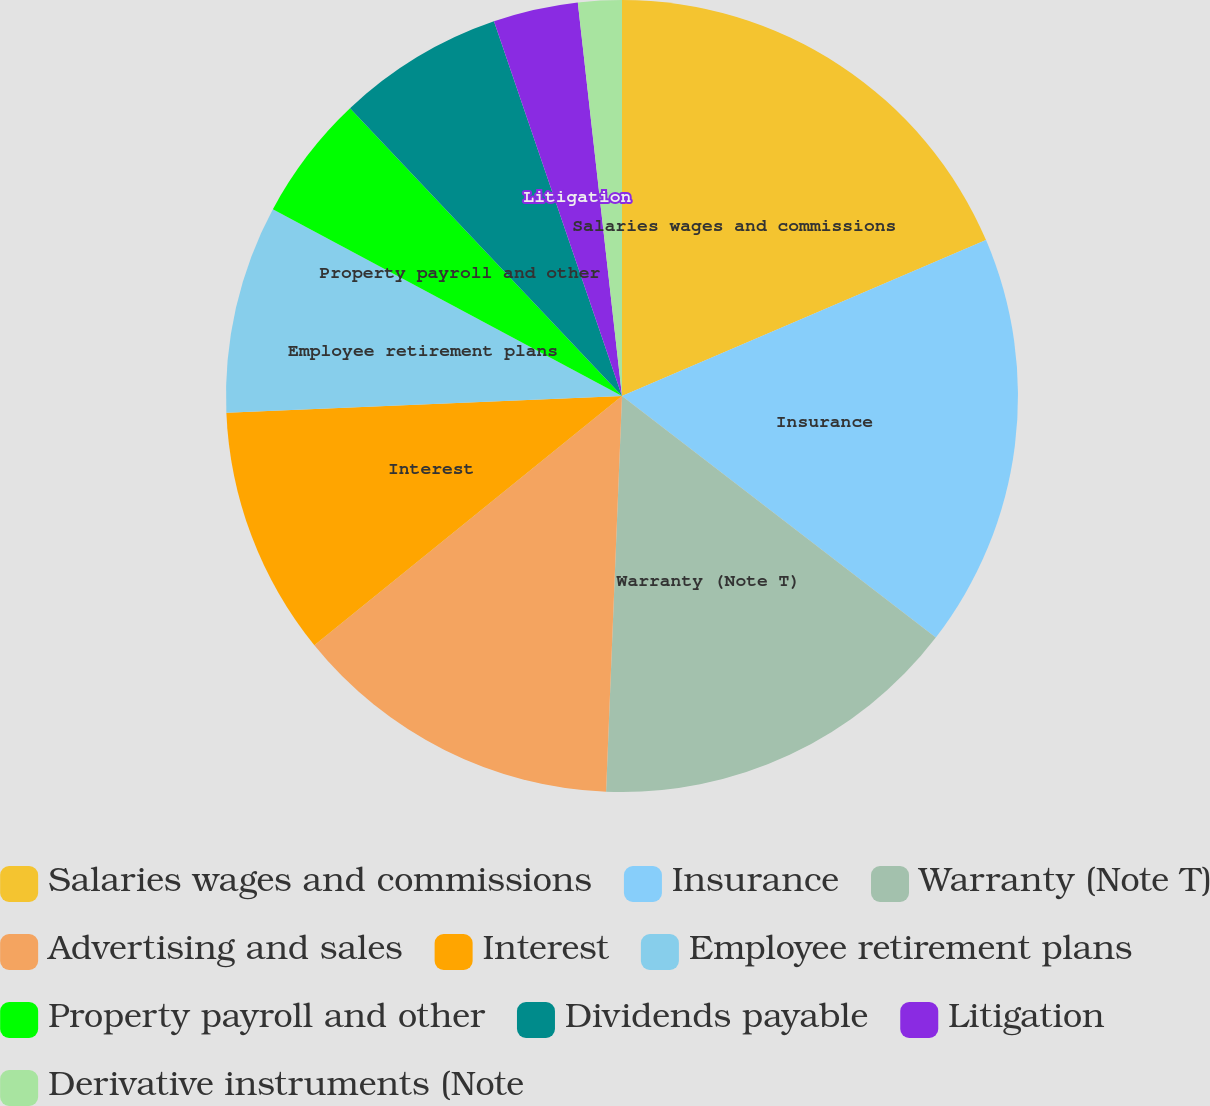<chart> <loc_0><loc_0><loc_500><loc_500><pie_chart><fcel>Salaries wages and commissions<fcel>Insurance<fcel>Warranty (Note T)<fcel>Advertising and sales<fcel>Interest<fcel>Employee retirement plans<fcel>Property payroll and other<fcel>Dividends payable<fcel>Litigation<fcel>Derivative instruments (Note<nl><fcel>18.56%<fcel>16.88%<fcel>15.2%<fcel>13.52%<fcel>10.17%<fcel>8.49%<fcel>5.13%<fcel>6.81%<fcel>3.46%<fcel>1.78%<nl></chart> 